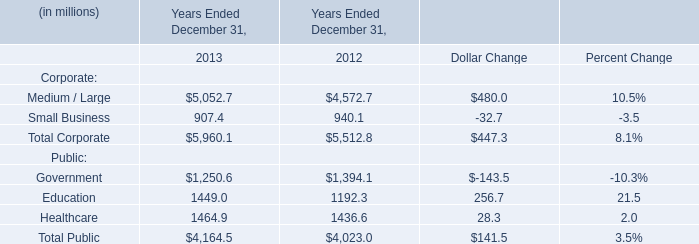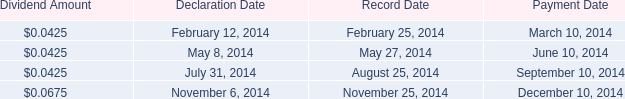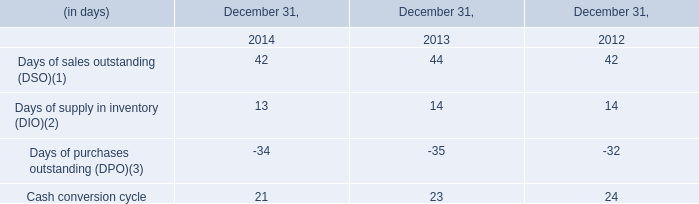What is the growing rate of healthcare in the year with the most education? 
Computations: ((1464.9 - 1436.6) / 1436.6)
Answer: 0.0197. 